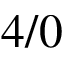<formula> <loc_0><loc_0><loc_500><loc_500>4 / 0</formula> 